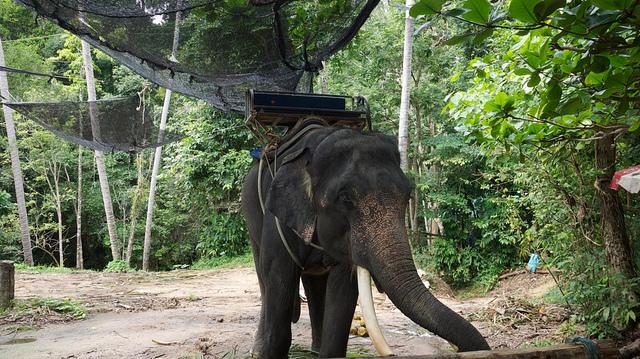Are there people riding the elephant?
Short answer required. No. Does the elephant have tusks?
Keep it brief. Yes. Is the elephant in the woods?
Concise answer only. Yes. What is on the animals back?
Concise answer only. Seat. 